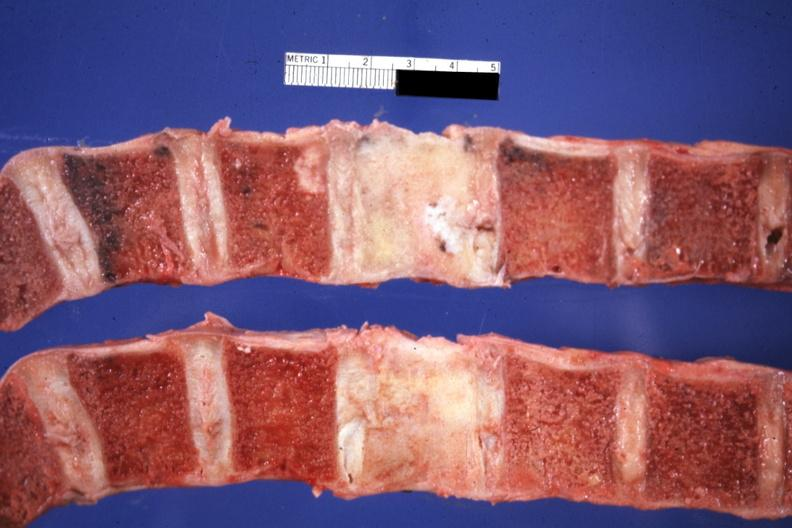s joints present?
Answer the question using a single word or phrase. Yes 